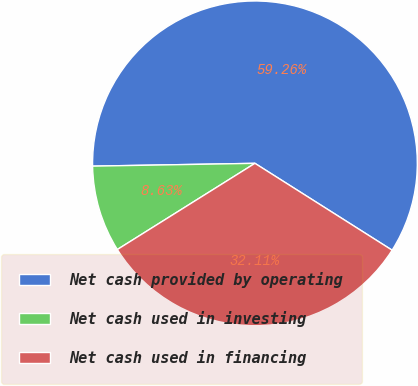Convert chart. <chart><loc_0><loc_0><loc_500><loc_500><pie_chart><fcel>Net cash provided by operating<fcel>Net cash used in investing<fcel>Net cash used in financing<nl><fcel>59.26%<fcel>8.63%<fcel>32.11%<nl></chart> 